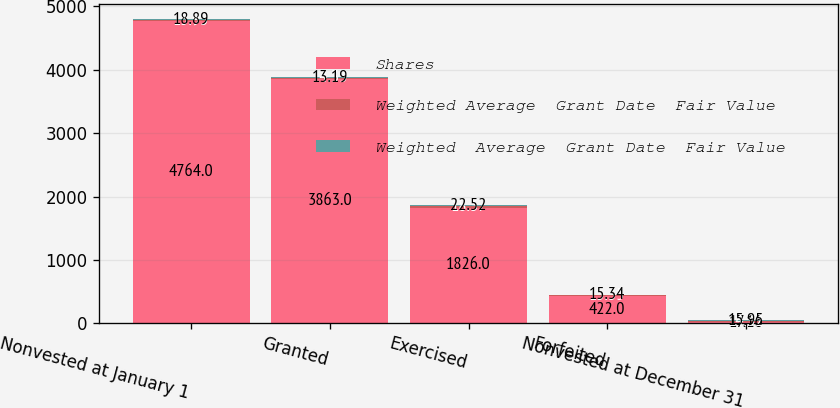Convert chart to OTSL. <chart><loc_0><loc_0><loc_500><loc_500><stacked_bar_chart><ecel><fcel>Nonvested at January 1<fcel>Granted<fcel>Exercised<fcel>Forfeited<fcel>Nonvested at December 31<nl><fcel>Shares<fcel>4764<fcel>3863<fcel>1826<fcel>422<fcel>17.16<nl><fcel>Weighted Average  Grant Date  Fair Value<fcel>15.95<fcel>14.33<fcel>18.37<fcel>15.35<fcel>14.32<nl><fcel>Weighted  Average  Grant Date  Fair Value<fcel>18.89<fcel>13.19<fcel>22.52<fcel>15.34<fcel>15.95<nl></chart> 